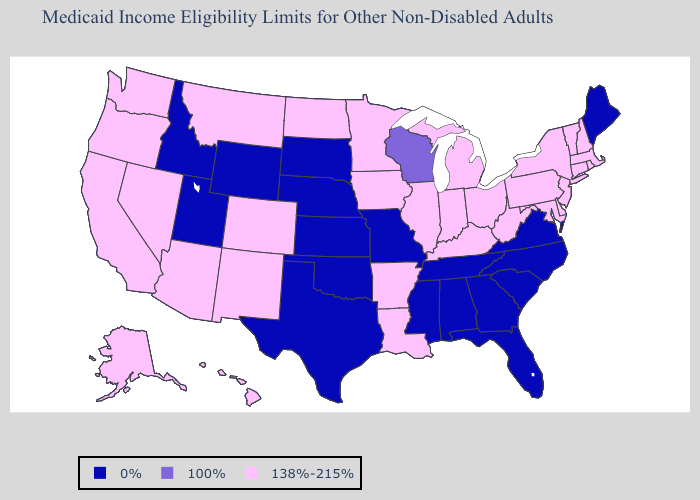Name the states that have a value in the range 100%?
Give a very brief answer. Wisconsin. Name the states that have a value in the range 100%?
Quick response, please. Wisconsin. What is the value of Mississippi?
Give a very brief answer. 0%. Does Missouri have a lower value than Maine?
Concise answer only. No. What is the highest value in states that border Kansas?
Quick response, please. 138%-215%. Does Nevada have a lower value than Missouri?
Concise answer only. No. Which states have the highest value in the USA?
Keep it brief. Alaska, Arizona, Arkansas, California, Colorado, Connecticut, Delaware, Hawaii, Illinois, Indiana, Iowa, Kentucky, Louisiana, Maryland, Massachusetts, Michigan, Minnesota, Montana, Nevada, New Hampshire, New Jersey, New Mexico, New York, North Dakota, Ohio, Oregon, Pennsylvania, Rhode Island, Vermont, Washington, West Virginia. Which states have the lowest value in the USA?
Be succinct. Alabama, Florida, Georgia, Idaho, Kansas, Maine, Mississippi, Missouri, Nebraska, North Carolina, Oklahoma, South Carolina, South Dakota, Tennessee, Texas, Utah, Virginia, Wyoming. Does Wisconsin have the highest value in the MidWest?
Give a very brief answer. No. How many symbols are there in the legend?
Give a very brief answer. 3. What is the lowest value in states that border Arkansas?
Short answer required. 0%. What is the value of Alabama?
Write a very short answer. 0%. What is the value of Maine?
Write a very short answer. 0%. Does Hawaii have the lowest value in the West?
Concise answer only. No. Name the states that have a value in the range 100%?
Answer briefly. Wisconsin. 